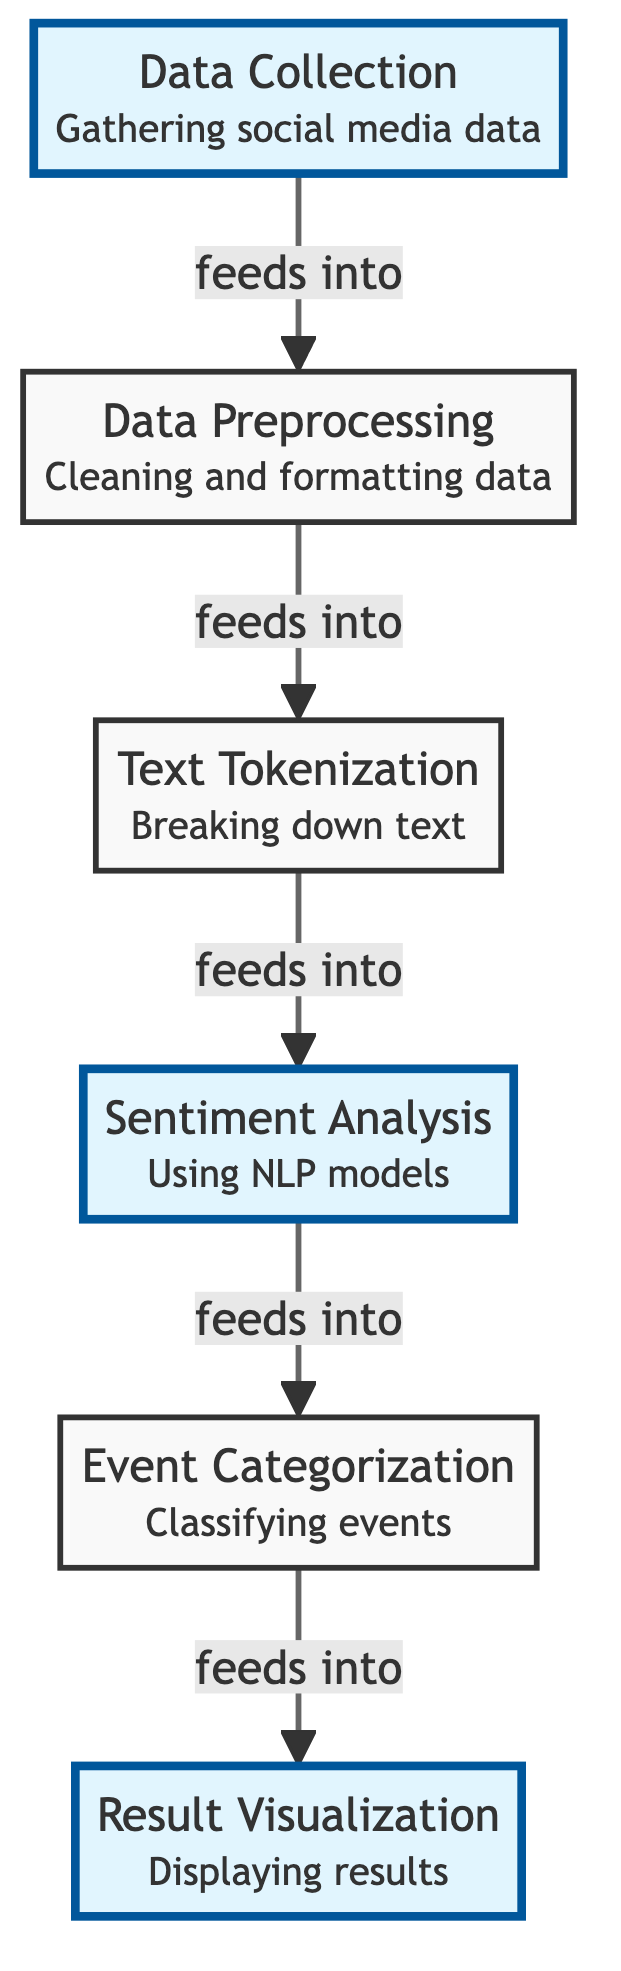What are the major steps in the diagram? The diagram outlines six major steps: Data Collection, Data Preprocessing, Text Tokenization, Sentiment Analysis, Event Categorization, and Result Visualization.
Answer: Data Collection, Data Preprocessing, Text Tokenization, Sentiment Analysis, Event Categorization, Result Visualization How many nodes are in the diagram? The diagram contains a total of six nodes, which represent the major steps in the analysis process.
Answer: Six What does the first node represent? The first node represents "Data Collection," which involves gathering social media data necessary for the analysis.
Answer: Data Collection Which node directly follows the Text Tokenization node? The Sentiment Analysis node directly follows the Text Tokenization node, indicating that the output from tokenization is fed into sentiment analysis.
Answer: Sentiment Analysis What is the relationship between the Data Preprocessing and Text Tokenization nodes? Data Preprocessing feeds into Text Tokenization, meaning after data is cleaned, it is then broken down into tokens.
Answer: Data Preprocessing feeds into Text Tokenization Which nodes are highlighted in the diagram? The highlighted nodes in the diagram are Data Collection, Sentiment Analysis, and Result Visualization, indicating key focus areas in the process.
Answer: Data Collection, Sentiment Analysis, Result Visualization How many edges are in this diagram? The diagram contains five edges, representing the flow from one step to another.
Answer: Five Which step involves classifying events? The Event Categorization node is responsible for classifying events based on sentiments derived from social media analysis.
Answer: Event Categorization 